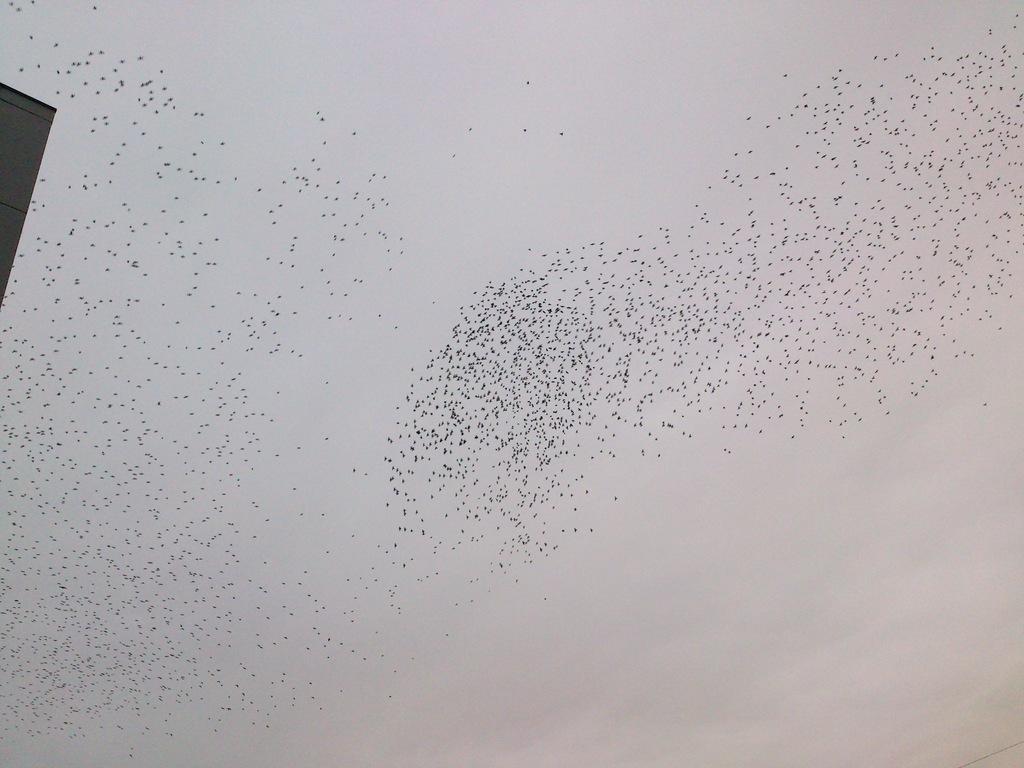Describe this image in one or two sentences. In this image we can see flock of birds in the sky. 